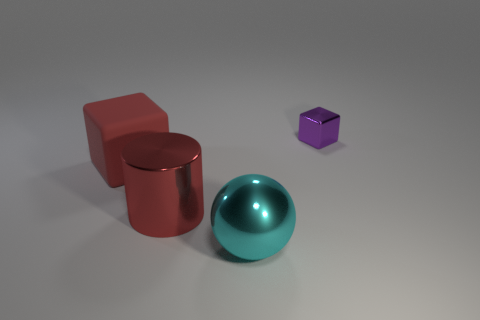Is there anything else that is the same material as the red cube?
Your response must be concise. No. Are there any other things that have the same shape as the big red metallic object?
Your answer should be very brief. No. Is the shape of the tiny purple object the same as the object that is left of the big red cylinder?
Your answer should be compact. Yes. What is the purple block made of?
Give a very brief answer. Metal. What size is the other purple thing that is the same shape as the big rubber thing?
Your response must be concise. Small. How many other objects are there of the same material as the big cyan object?
Provide a short and direct response. 2. Are the small thing and the big thing in front of the large metal cylinder made of the same material?
Your answer should be very brief. Yes. Are there fewer objects that are left of the small purple metallic block than large cyan metallic things behind the big cyan metal ball?
Keep it short and to the point. No. There is a block that is right of the large cyan object; what is its color?
Keep it short and to the point. Purple. What number of other objects are there of the same color as the large rubber object?
Give a very brief answer. 1. 